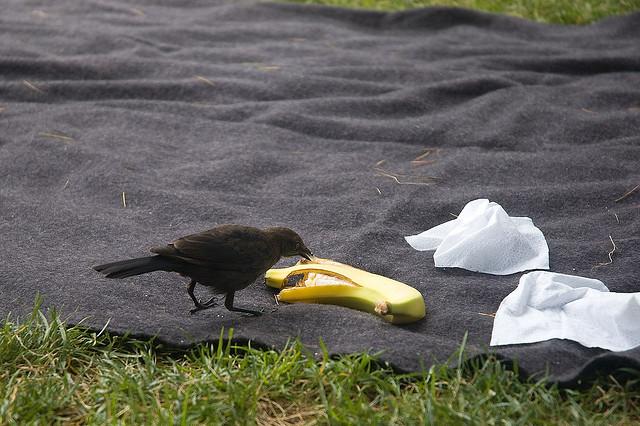What is on the blanket other than a bird and banana?
Write a very short answer. Tissue. What color is the bird?
Write a very short answer. Black. Are there other animals?
Answer briefly. No. 